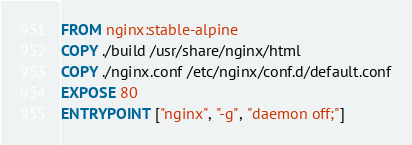Convert code to text. <code><loc_0><loc_0><loc_500><loc_500><_Dockerfile_>FROM nginx:stable-alpine
COPY ./build /usr/share/nginx/html
COPY ./nginx.conf /etc/nginx/conf.d/default.conf
EXPOSE 80
ENTRYPOINT ["nginx", "-g", "daemon off;"]</code> 